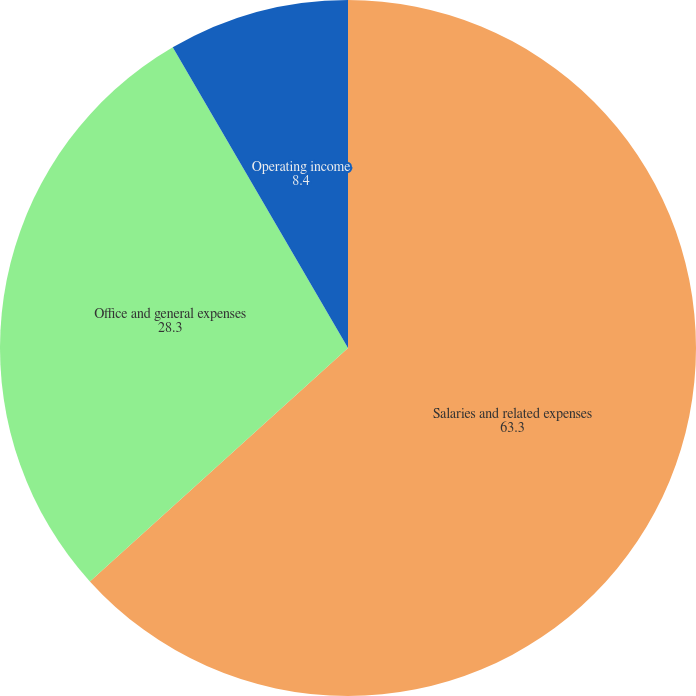Convert chart to OTSL. <chart><loc_0><loc_0><loc_500><loc_500><pie_chart><fcel>Salaries and related expenses<fcel>Office and general expenses<fcel>Operating income<nl><fcel>63.3%<fcel>28.3%<fcel>8.4%<nl></chart> 